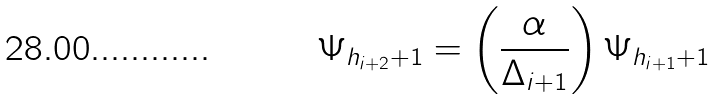<formula> <loc_0><loc_0><loc_500><loc_500>\Psi _ { h _ { i + 2 } + 1 } = \left ( \frac { \alpha } { \Delta _ { i + 1 } } \right ) \Psi _ { h _ { i + 1 } + 1 }</formula> 